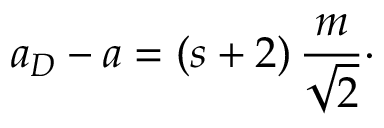<formula> <loc_0><loc_0><loc_500><loc_500>a _ { D } - a = ( s + 2 ) \, { \frac { m } { \sqrt { 2 } } } \cdot</formula> 